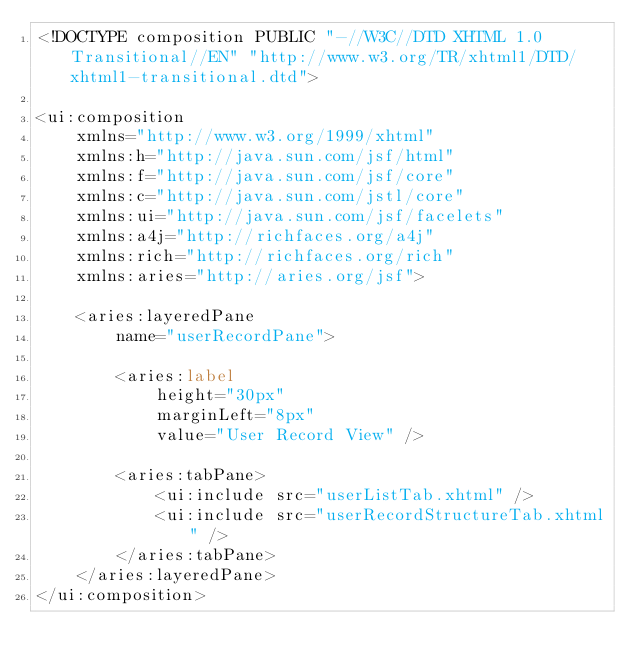<code> <loc_0><loc_0><loc_500><loc_500><_HTML_><!DOCTYPE composition PUBLIC "-//W3C//DTD XHTML 1.0 Transitional//EN" "http://www.w3.org/TR/xhtml1/DTD/xhtml1-transitional.dtd">

<ui:composition 
	xmlns="http://www.w3.org/1999/xhtml"
	xmlns:h="http://java.sun.com/jsf/html"
	xmlns:f="http://java.sun.com/jsf/core"
	xmlns:c="http://java.sun.com/jstl/core"	
	xmlns:ui="http://java.sun.com/jsf/facelets"
	xmlns:a4j="http://richfaces.org/a4j"
	xmlns:rich="http://richfaces.org/rich"
	xmlns:aries="http://aries.org/jsf">

	<aries:layeredPane
		name="userRecordPane">

		<aries:label 
			height="30px" 
			marginLeft="8px"
			value="User Record View" />
		
		<aries:tabPane>
			<ui:include src="userListTab.xhtml" />
			<ui:include src="userRecordStructureTab.xhtml" />
		</aries:tabPane>
	</aries:layeredPane>
</ui:composition>
</code> 